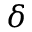Convert formula to latex. <formula><loc_0><loc_0><loc_500><loc_500>\delta</formula> 